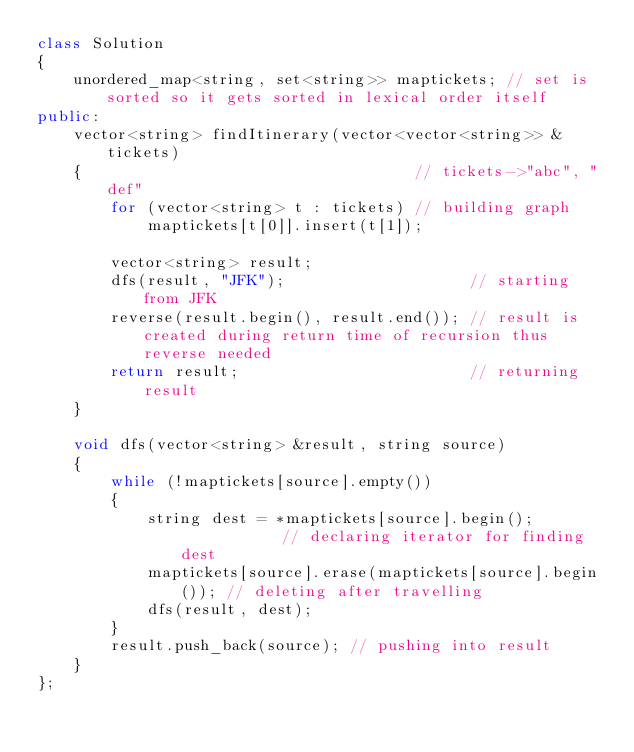<code> <loc_0><loc_0><loc_500><loc_500><_C++_>class Solution
{
    unordered_map<string, set<string>> maptickets; // set is sorted so it gets sorted in lexical order itself
public:
    vector<string> findItinerary(vector<vector<string>> &tickets)
    {                                    // tickets->"abc", "def"
        for (vector<string> t : tickets) // building graph
            maptickets[t[0]].insert(t[1]);

        vector<string> result;
        dfs(result, "JFK");                    // starting from JFK
        reverse(result.begin(), result.end()); // result is created during return time of recursion thus reverse needed
        return result;                         // returning result
    }

    void dfs(vector<string> &result, string source)
    {
        while (!maptickets[source].empty())
        {
            string dest = *maptickets[source].begin();            // declaring iterator for finding dest
            maptickets[source].erase(maptickets[source].begin()); // deleting after travelling
            dfs(result, dest);
        }
        result.push_back(source); // pushing into result
    }
};</code> 